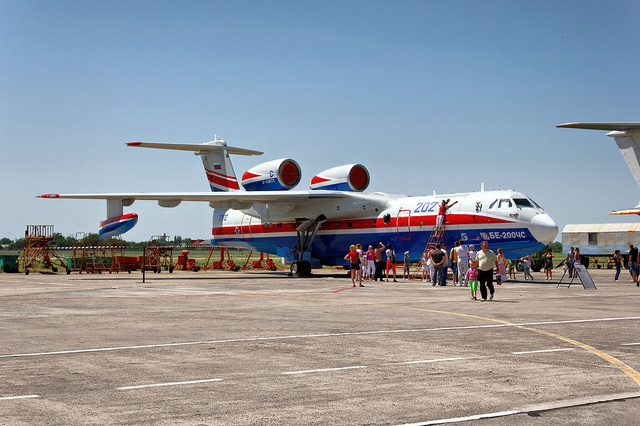Describe the objects in this image and their specific colors. I can see airplane in darkgray, gray, white, navy, and black tones, people in darkgray, black, gray, maroon, and navy tones, people in darkgray, black, gray, and maroon tones, people in darkgray, gray, and lightgray tones, and people in darkgray, maroon, black, and brown tones in this image. 